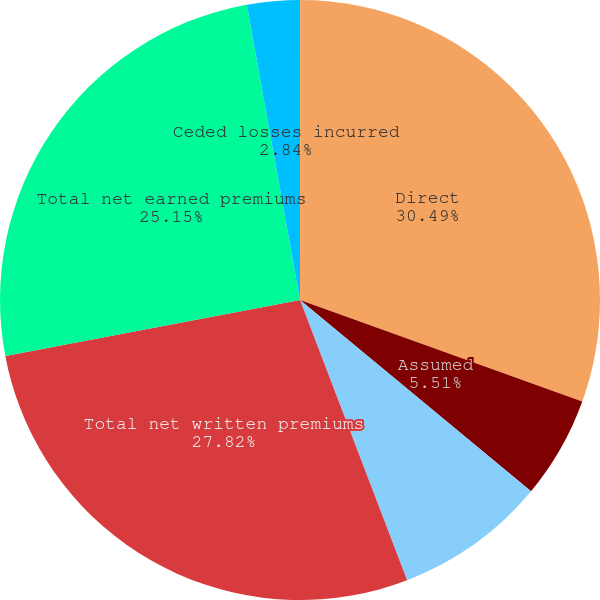Convert chart to OTSL. <chart><loc_0><loc_0><loc_500><loc_500><pie_chart><fcel>(In thousands)<fcel>Direct<fcel>Assumed<fcel>Ceded<fcel>Total net written premiums<fcel>Total net earned premiums<fcel>Ceded losses incurred<nl><fcel>0.01%<fcel>30.49%<fcel>5.51%<fcel>8.18%<fcel>27.82%<fcel>25.15%<fcel>2.84%<nl></chart> 